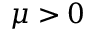Convert formula to latex. <formula><loc_0><loc_0><loc_500><loc_500>\mu > 0</formula> 